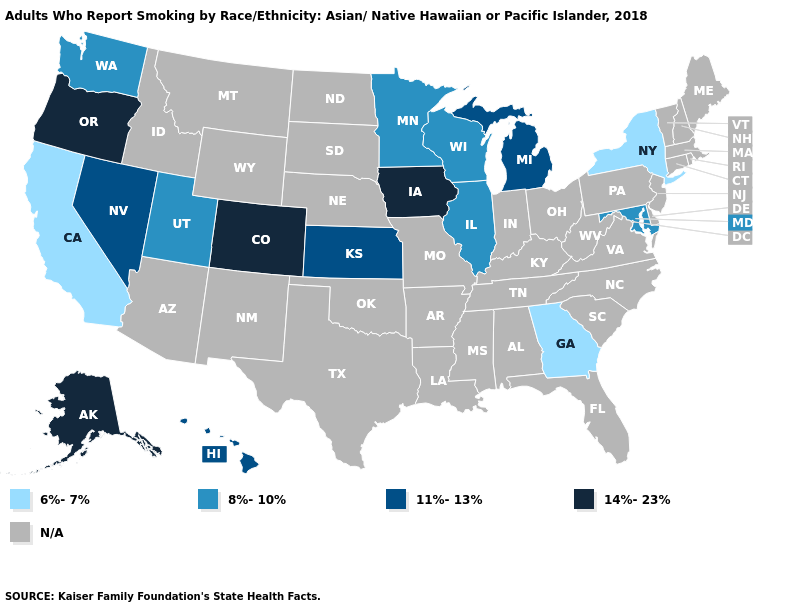Which states have the highest value in the USA?
Quick response, please. Alaska, Colorado, Iowa, Oregon. Does the first symbol in the legend represent the smallest category?
Be succinct. Yes. Does Georgia have the lowest value in the USA?
Short answer required. Yes. Which states have the lowest value in the USA?
Be succinct. California, Georgia, New York. What is the value of Kansas?
Quick response, please. 11%-13%. Name the states that have a value in the range 14%-23%?
Answer briefly. Alaska, Colorado, Iowa, Oregon. Name the states that have a value in the range N/A?
Quick response, please. Alabama, Arizona, Arkansas, Connecticut, Delaware, Florida, Idaho, Indiana, Kentucky, Louisiana, Maine, Massachusetts, Mississippi, Missouri, Montana, Nebraska, New Hampshire, New Jersey, New Mexico, North Carolina, North Dakota, Ohio, Oklahoma, Pennsylvania, Rhode Island, South Carolina, South Dakota, Tennessee, Texas, Vermont, Virginia, West Virginia, Wyoming. Does Georgia have the lowest value in the South?
Write a very short answer. Yes. Does the map have missing data?
Write a very short answer. Yes. What is the highest value in the MidWest ?
Quick response, please. 14%-23%. 